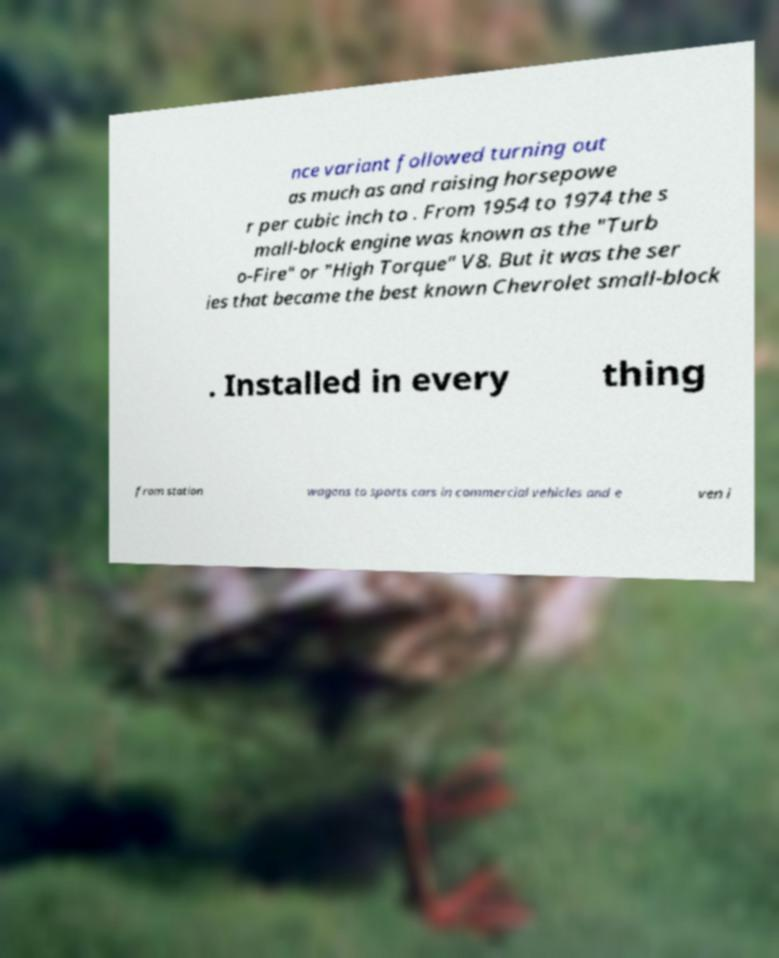Can you accurately transcribe the text from the provided image for me? nce variant followed turning out as much as and raising horsepowe r per cubic inch to . From 1954 to 1974 the s mall-block engine was known as the "Turb o-Fire" or "High Torque" V8. But it was the ser ies that became the best known Chevrolet small-block . Installed in every thing from station wagons to sports cars in commercial vehicles and e ven i 